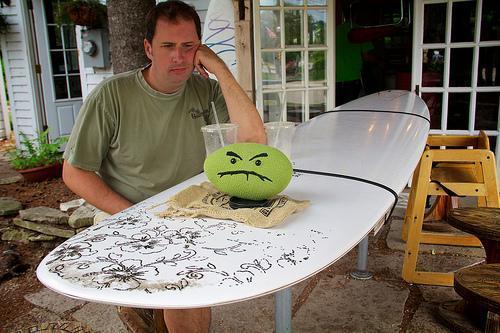How many people are in this picture?
Give a very brief answer. 1. 